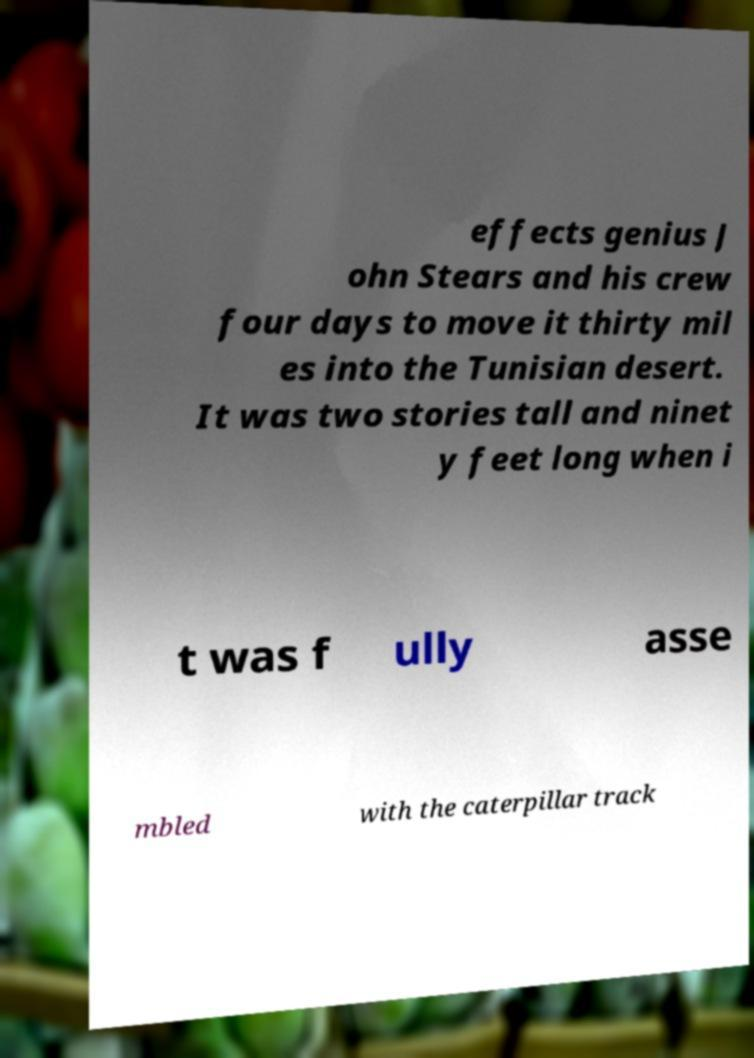Can you accurately transcribe the text from the provided image for me? effects genius J ohn Stears and his crew four days to move it thirty mil es into the Tunisian desert. It was two stories tall and ninet y feet long when i t was f ully asse mbled with the caterpillar track 